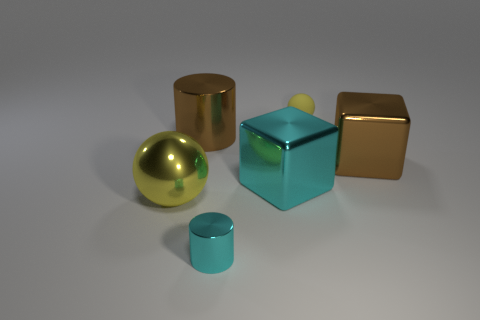Add 2 big brown cubes. How many objects exist? 8 Subtract all blocks. How many objects are left? 4 Add 3 small yellow things. How many small yellow things exist? 4 Subtract 0 blue cubes. How many objects are left? 6 Subtract all brown cubes. Subtract all cyan blocks. How many objects are left? 4 Add 1 tiny rubber objects. How many tiny rubber objects are left? 2 